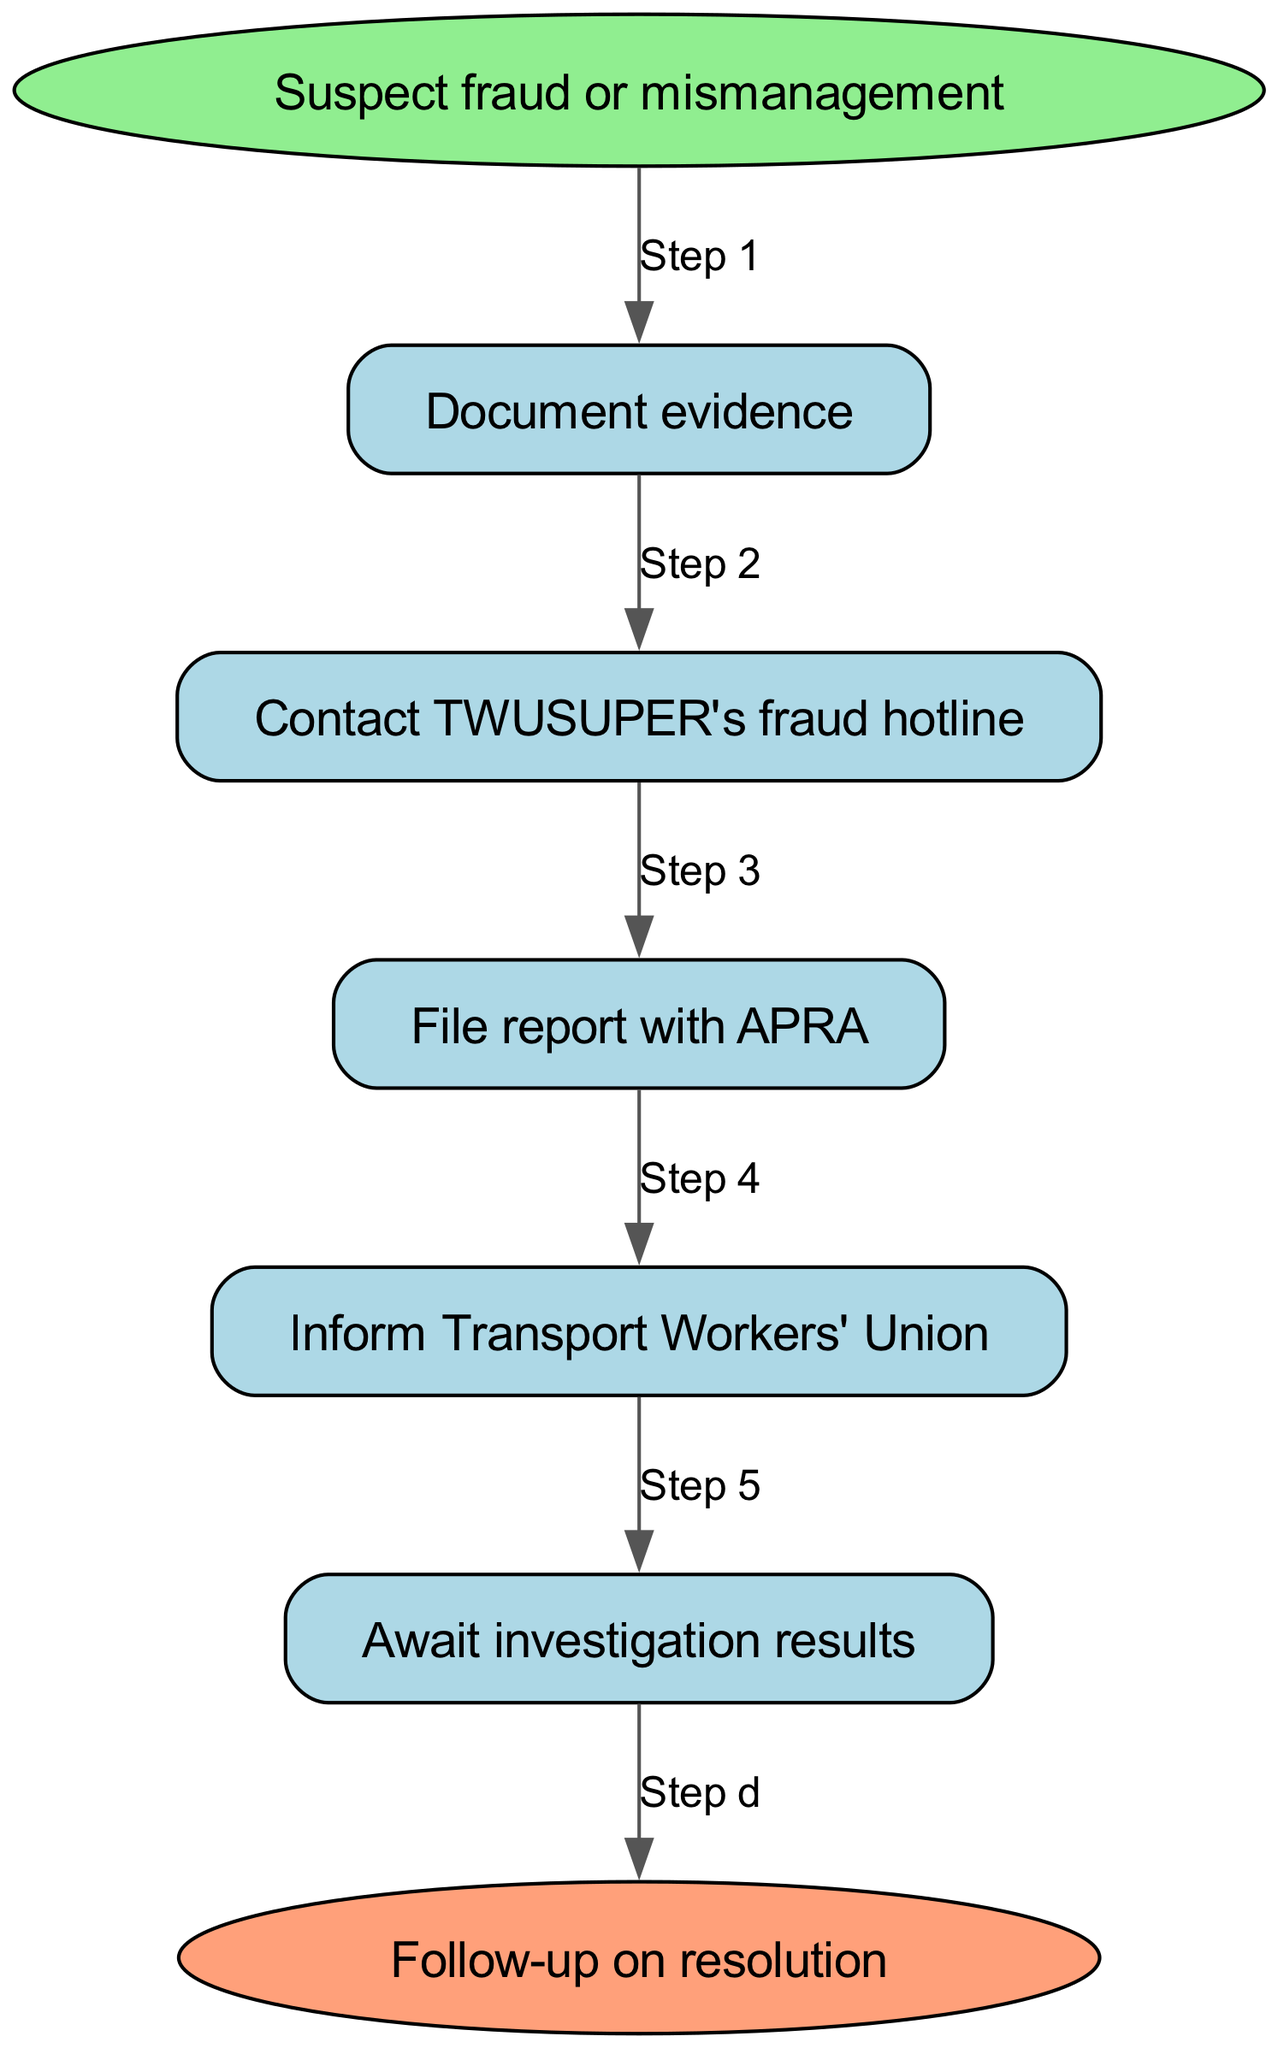What is the first step when you suspect fraud or mismanagement? The first step indicated in the diagram after “Suspect fraud or mismanagement” is to “Document evidence.” The flow proceeds directly from the start node to this first step.
Answer: Document evidence How many main steps are involved in reporting potential fraud or mismanagement? By counting the steps listed in the diagram, there are five main steps included between the start and the end points, which are documented evidence, contacting the fraud hotline, filing a report with APRA, informing the union, and awaiting investigation results.
Answer: Five Which node comes immediately after “Contact TWUSUPER's fraud hotline”? Looking at the connections from the “Contact TWUSUPER's fraud hotline” node, the next node in the flow is “File report with APRA.” This indicates the progression from reporting the hotline to filing a formal report.
Answer: File report with APRA What is the last step in the process? According to the diagram, after awaiting the results of the investigation, the last step indicated is to “Follow-up on resolution.” This points to the completion of the process after the investigation's outcome.
Answer: Follow-up on resolution What action should be taken after filing a report with APRA? The diagram shows that after filing a report with APRA, the next action is to “Inform Transport Workers' Union.” This indicates the necessary communication to keep the union informed following the report.
Answer: Inform Transport Workers' Union What shape is used to represent the starting point in this flowchart? In the flowchart, the starting point “Suspect fraud or mismanagement” is represented in an ellipse shape, indicating it as the entry point of the process.
Answer: Ellipse What does each edge connecting the nodes represent? Each edge in the diagram represents a sequential step in the process of reporting potential fraud or mismanagement, illustrating the flow from one action to the next in a clear order.
Answer: Sequential step Which step comes before “Await investigation results”? The step that comes directly before “Await investigation results” is “Inform Transport Workers' Union.” This shows the action taken in communication before waiting for any investigation outcomes.
Answer: Inform Transport Workers' Union 